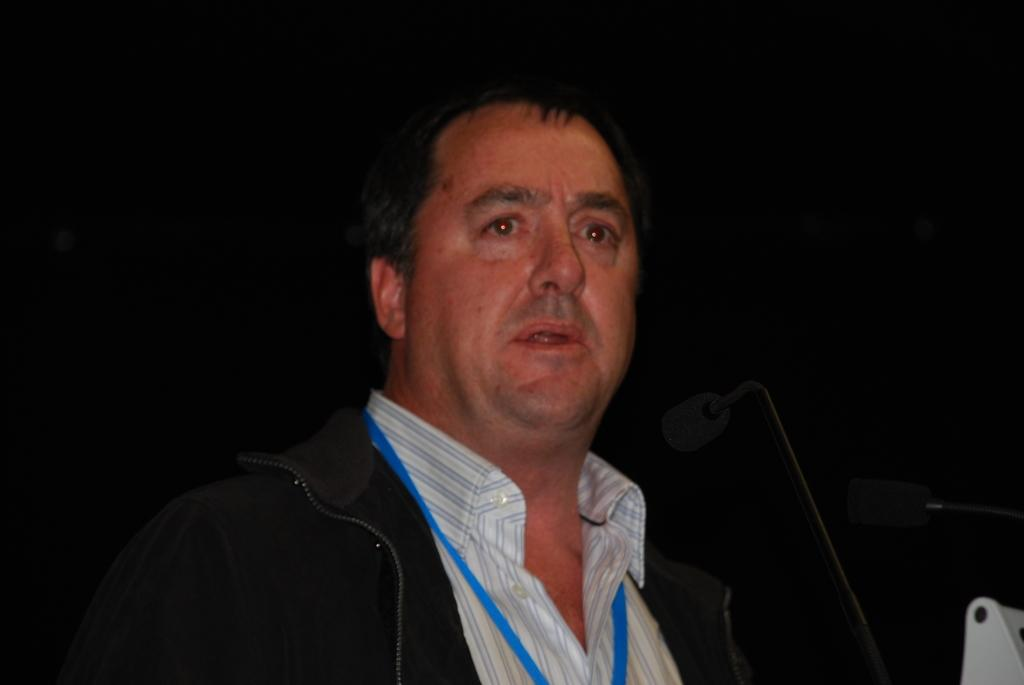What is the main subject of the image? There is a man in the image. What is the man doing in the image? The man is standing in the image. What is the man wearing on his upper body? The man is wearing a black jacket and a white shirt. What can be seen on the man's clothing? The man has a blue tag on his clothing. What object is near the man in the image? There is a microphone near the man in the image. What type of paste is the man using to stick the sack to the wall in the image? There is no sack or paste present in the image; the man is simply standing with a microphone nearby. 